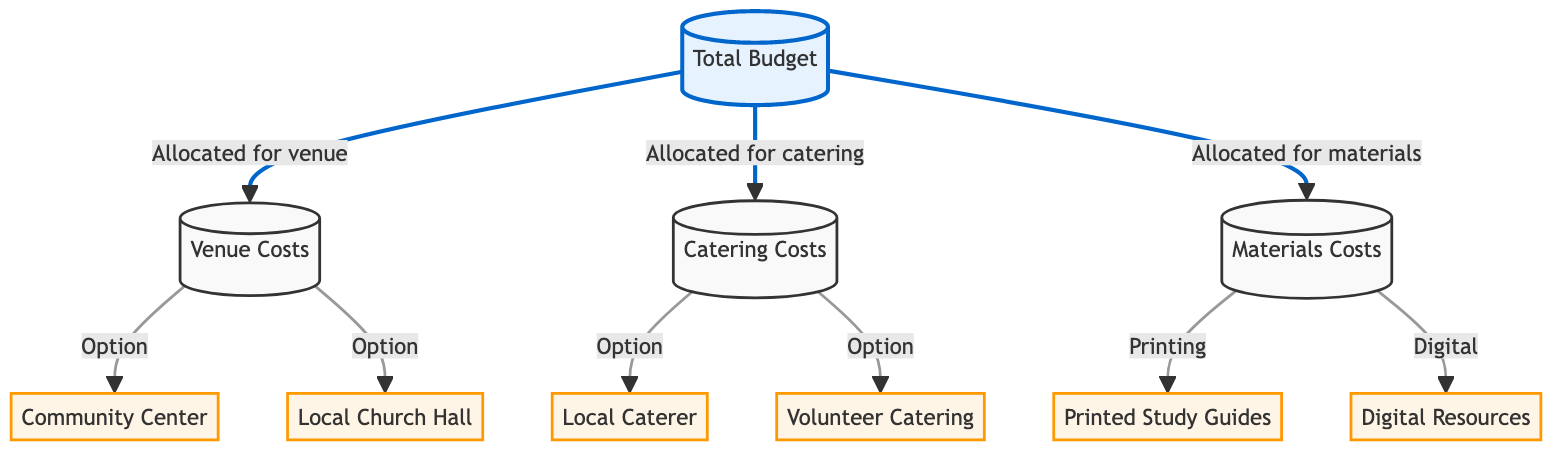What are the three main categories of budget allocation? The diagram outlines three main categories for budget allocation linked to the total budget: Venue Costs, Catering Costs, and Materials Costs. These are the only categories explicitly mentioned.
Answer: Venue Costs, Catering Costs, Materials Costs How many options are available for venue costs? There are two options listed under the Venue Costs node: Community Center and Local Church Hall. Therefore, the total count of options for venue costs is two.
Answer: 2 Which catering option employs volunteers? The diagram presents Volunteer Catering as one of the options under Catering Costs. Based on the information in the diagram, Volunteer Catering is the only option specified that employs volunteers.
Answer: Volunteer Catering What are the two types of materials costs indicated in the diagram? The diagram specifies two types of materials costs: Printed Study Guides and Digital Resources. This information is clearly represented under the Materials Costs node.
Answer: Printed Study Guides, Digital Resources If the total budget is $1,000, how many sections does it divide into based on the diagram? The total budget divides into three sections as indicated by the arrows leading to Venue Costs, Catering Costs, and Materials Costs. Each of these sections corresponds directly to a category of allocation.
Answer: 3 What color represents the main budget node in the diagram? The main budget node is highlighted with a fill color of light blue, as indicated by the class definition for the main nodes. This color is consistent across the presentation of the main budget node.
Answer: Light blue Which option is classified under materials costs related to printing? The diagram categorizes Printed Study Guides specifically under the materials costs and indicates it as an option. This explicitly connects the printing aspect to the materials costs.
Answer: Printed Study Guides Which node links directly to the Total Budget node? The Total Budget node connects directly to three nodes: Venue Costs, Catering Costs, and Materials Costs. Each of these represents a major component of the overall budget allocation.
Answer: Venue Costs, Catering Costs, Materials Costs How many distinct nodes are classified as options for catering costs? Under the Catering Costs node, there are two distinct options listed: Local Caterer and Volunteer Catering. This creates a total of two options specifically for this section.
Answer: 2 